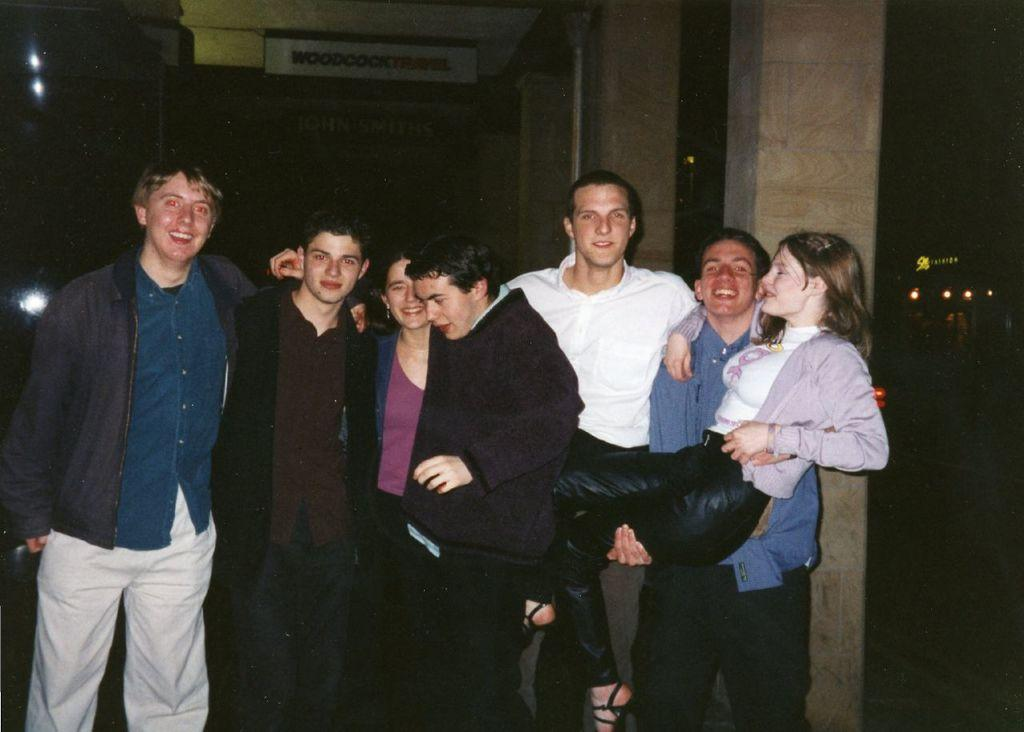How many persons are visible in the image? There are persons standing in the image. What is the man doing in the image? A man is carrying a woman in the image. What architectural features can be seen in the image? There are pillars in the image. What objects are present in the image? There are boards and lights in the image. What is the color of the background in the image? The background of the image is dark. What type of system is being used by the persons to sleep in the image? There is no indication in the image that the persons are sleeping or using any system for sleeping. 